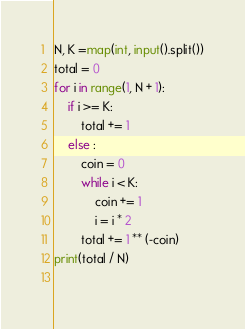Convert code to text. <code><loc_0><loc_0><loc_500><loc_500><_Python_>N, K =map(int, input().split())
total = 0
for i in range(1, N + 1):
    if i >= K:
        total += 1
    else :
        coin = 0
        while i < K:
            coin += 1
            i = i * 2
        total += 1 ** (-coin)
print(total / N)
        
</code> 